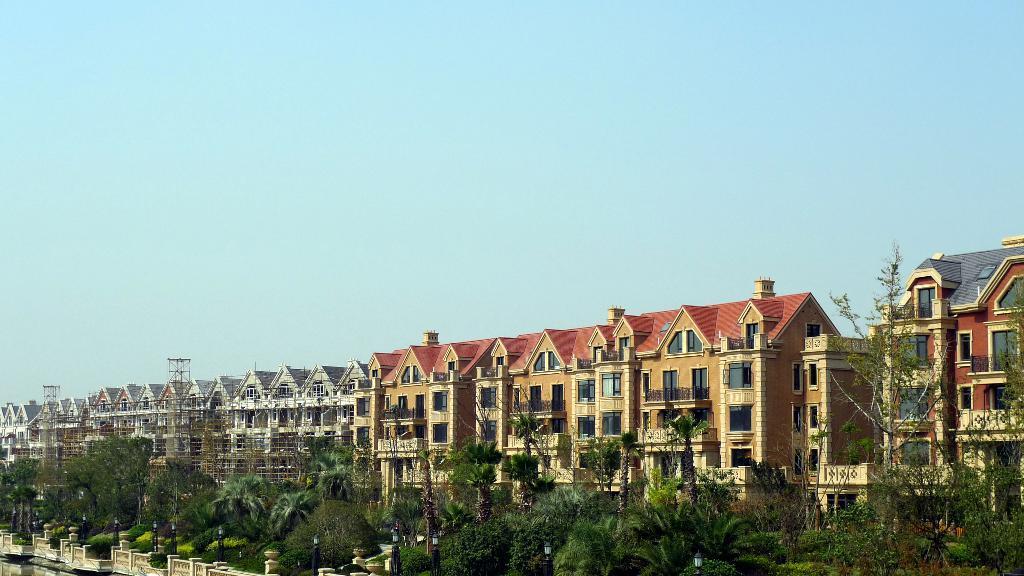Can you describe this image briefly? There are trees and buildings. There is fence and water at the left. 